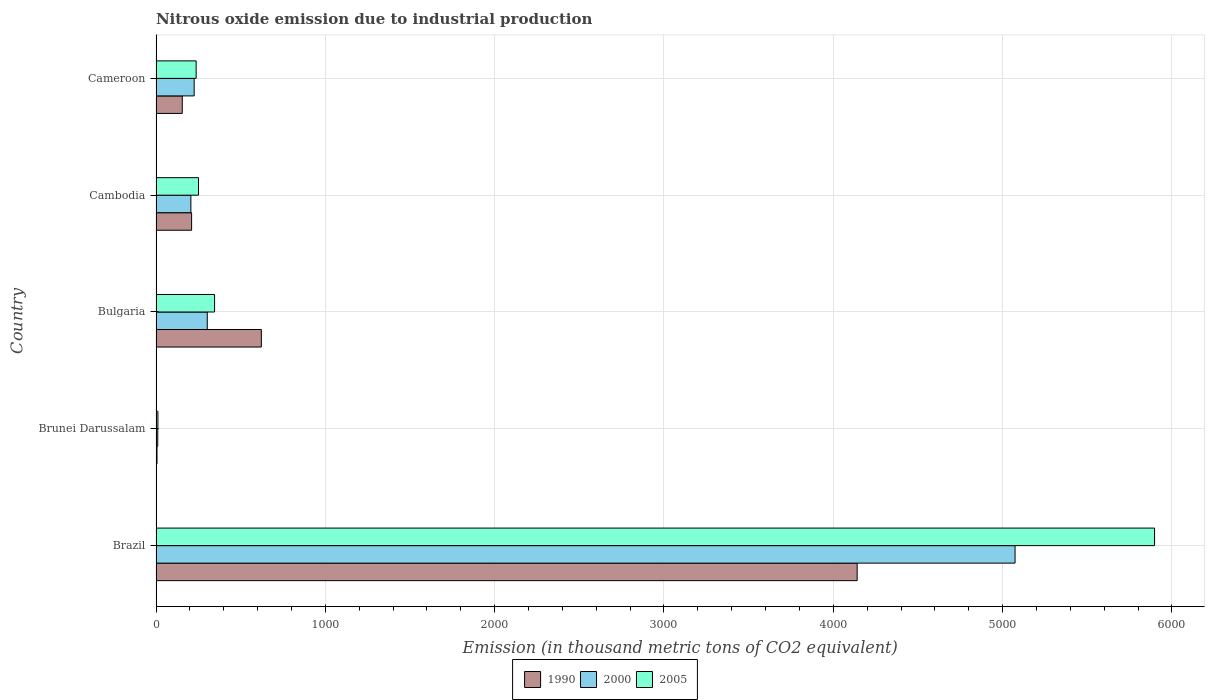How many different coloured bars are there?
Your answer should be very brief. 3. Are the number of bars per tick equal to the number of legend labels?
Your response must be concise. Yes. How many bars are there on the 4th tick from the top?
Your response must be concise. 3. What is the amount of nitrous oxide emitted in 1990 in Brunei Darussalam?
Your answer should be very brief. 5.9. Across all countries, what is the maximum amount of nitrous oxide emitted in 1990?
Your answer should be very brief. 4140.8. Across all countries, what is the minimum amount of nitrous oxide emitted in 2005?
Offer a very short reply. 11.1. In which country was the amount of nitrous oxide emitted in 2005 minimum?
Provide a short and direct response. Brunei Darussalam. What is the total amount of nitrous oxide emitted in 1990 in the graph?
Give a very brief answer. 5133.9. What is the difference between the amount of nitrous oxide emitted in 1990 in Bulgaria and that in Cameroon?
Your answer should be compact. 467. What is the difference between the amount of nitrous oxide emitted in 2005 in Brunei Darussalam and the amount of nitrous oxide emitted in 2000 in Bulgaria?
Give a very brief answer. -291.5. What is the average amount of nitrous oxide emitted in 2005 per country?
Ensure brevity in your answer.  1348.42. What is the difference between the amount of nitrous oxide emitted in 2005 and amount of nitrous oxide emitted in 1990 in Cameroon?
Make the answer very short. 81.9. What is the ratio of the amount of nitrous oxide emitted in 2005 in Brazil to that in Cambodia?
Provide a succinct answer. 23.5. What is the difference between the highest and the second highest amount of nitrous oxide emitted in 2005?
Offer a terse response. 5551.5. What is the difference between the highest and the lowest amount of nitrous oxide emitted in 2000?
Keep it short and to the point. 5063.1. In how many countries, is the amount of nitrous oxide emitted in 2000 greater than the average amount of nitrous oxide emitted in 2000 taken over all countries?
Your response must be concise. 1. Is it the case that in every country, the sum of the amount of nitrous oxide emitted in 2005 and amount of nitrous oxide emitted in 1990 is greater than the amount of nitrous oxide emitted in 2000?
Provide a succinct answer. Yes. What is the difference between two consecutive major ticks on the X-axis?
Ensure brevity in your answer.  1000. Does the graph contain any zero values?
Your answer should be very brief. No. Does the graph contain grids?
Ensure brevity in your answer.  Yes. How many legend labels are there?
Ensure brevity in your answer.  3. What is the title of the graph?
Your response must be concise. Nitrous oxide emission due to industrial production. What is the label or title of the X-axis?
Keep it short and to the point. Emission (in thousand metric tons of CO2 equivalent). What is the label or title of the Y-axis?
Offer a very short reply. Country. What is the Emission (in thousand metric tons of CO2 equivalent) in 1990 in Brazil?
Give a very brief answer. 4140.8. What is the Emission (in thousand metric tons of CO2 equivalent) in 2000 in Brazil?
Ensure brevity in your answer.  5073.4. What is the Emission (in thousand metric tons of CO2 equivalent) in 2005 in Brazil?
Provide a short and direct response. 5897.3. What is the Emission (in thousand metric tons of CO2 equivalent) of 2000 in Brunei Darussalam?
Give a very brief answer. 10.3. What is the Emission (in thousand metric tons of CO2 equivalent) in 2005 in Brunei Darussalam?
Make the answer very short. 11.1. What is the Emission (in thousand metric tons of CO2 equivalent) of 1990 in Bulgaria?
Your response must be concise. 622. What is the Emission (in thousand metric tons of CO2 equivalent) in 2000 in Bulgaria?
Your answer should be very brief. 302.6. What is the Emission (in thousand metric tons of CO2 equivalent) of 2005 in Bulgaria?
Give a very brief answer. 345.8. What is the Emission (in thousand metric tons of CO2 equivalent) in 1990 in Cambodia?
Provide a succinct answer. 210.2. What is the Emission (in thousand metric tons of CO2 equivalent) in 2000 in Cambodia?
Your response must be concise. 205.8. What is the Emission (in thousand metric tons of CO2 equivalent) in 2005 in Cambodia?
Your response must be concise. 251. What is the Emission (in thousand metric tons of CO2 equivalent) in 1990 in Cameroon?
Offer a very short reply. 155. What is the Emission (in thousand metric tons of CO2 equivalent) in 2000 in Cameroon?
Keep it short and to the point. 225.2. What is the Emission (in thousand metric tons of CO2 equivalent) of 2005 in Cameroon?
Ensure brevity in your answer.  236.9. Across all countries, what is the maximum Emission (in thousand metric tons of CO2 equivalent) of 1990?
Make the answer very short. 4140.8. Across all countries, what is the maximum Emission (in thousand metric tons of CO2 equivalent) in 2000?
Make the answer very short. 5073.4. Across all countries, what is the maximum Emission (in thousand metric tons of CO2 equivalent) in 2005?
Provide a succinct answer. 5897.3. What is the total Emission (in thousand metric tons of CO2 equivalent) in 1990 in the graph?
Ensure brevity in your answer.  5133.9. What is the total Emission (in thousand metric tons of CO2 equivalent) of 2000 in the graph?
Provide a succinct answer. 5817.3. What is the total Emission (in thousand metric tons of CO2 equivalent) of 2005 in the graph?
Provide a succinct answer. 6742.1. What is the difference between the Emission (in thousand metric tons of CO2 equivalent) in 1990 in Brazil and that in Brunei Darussalam?
Provide a short and direct response. 4134.9. What is the difference between the Emission (in thousand metric tons of CO2 equivalent) in 2000 in Brazil and that in Brunei Darussalam?
Offer a very short reply. 5063.1. What is the difference between the Emission (in thousand metric tons of CO2 equivalent) in 2005 in Brazil and that in Brunei Darussalam?
Ensure brevity in your answer.  5886.2. What is the difference between the Emission (in thousand metric tons of CO2 equivalent) in 1990 in Brazil and that in Bulgaria?
Offer a terse response. 3518.8. What is the difference between the Emission (in thousand metric tons of CO2 equivalent) of 2000 in Brazil and that in Bulgaria?
Provide a short and direct response. 4770.8. What is the difference between the Emission (in thousand metric tons of CO2 equivalent) of 2005 in Brazil and that in Bulgaria?
Ensure brevity in your answer.  5551.5. What is the difference between the Emission (in thousand metric tons of CO2 equivalent) in 1990 in Brazil and that in Cambodia?
Make the answer very short. 3930.6. What is the difference between the Emission (in thousand metric tons of CO2 equivalent) of 2000 in Brazil and that in Cambodia?
Ensure brevity in your answer.  4867.6. What is the difference between the Emission (in thousand metric tons of CO2 equivalent) in 2005 in Brazil and that in Cambodia?
Provide a succinct answer. 5646.3. What is the difference between the Emission (in thousand metric tons of CO2 equivalent) in 1990 in Brazil and that in Cameroon?
Provide a succinct answer. 3985.8. What is the difference between the Emission (in thousand metric tons of CO2 equivalent) of 2000 in Brazil and that in Cameroon?
Offer a very short reply. 4848.2. What is the difference between the Emission (in thousand metric tons of CO2 equivalent) in 2005 in Brazil and that in Cameroon?
Your answer should be compact. 5660.4. What is the difference between the Emission (in thousand metric tons of CO2 equivalent) of 1990 in Brunei Darussalam and that in Bulgaria?
Give a very brief answer. -616.1. What is the difference between the Emission (in thousand metric tons of CO2 equivalent) in 2000 in Brunei Darussalam and that in Bulgaria?
Provide a short and direct response. -292.3. What is the difference between the Emission (in thousand metric tons of CO2 equivalent) of 2005 in Brunei Darussalam and that in Bulgaria?
Your response must be concise. -334.7. What is the difference between the Emission (in thousand metric tons of CO2 equivalent) of 1990 in Brunei Darussalam and that in Cambodia?
Give a very brief answer. -204.3. What is the difference between the Emission (in thousand metric tons of CO2 equivalent) in 2000 in Brunei Darussalam and that in Cambodia?
Keep it short and to the point. -195.5. What is the difference between the Emission (in thousand metric tons of CO2 equivalent) of 2005 in Brunei Darussalam and that in Cambodia?
Keep it short and to the point. -239.9. What is the difference between the Emission (in thousand metric tons of CO2 equivalent) of 1990 in Brunei Darussalam and that in Cameroon?
Your answer should be very brief. -149.1. What is the difference between the Emission (in thousand metric tons of CO2 equivalent) in 2000 in Brunei Darussalam and that in Cameroon?
Provide a succinct answer. -214.9. What is the difference between the Emission (in thousand metric tons of CO2 equivalent) in 2005 in Brunei Darussalam and that in Cameroon?
Your answer should be very brief. -225.8. What is the difference between the Emission (in thousand metric tons of CO2 equivalent) in 1990 in Bulgaria and that in Cambodia?
Provide a short and direct response. 411.8. What is the difference between the Emission (in thousand metric tons of CO2 equivalent) in 2000 in Bulgaria and that in Cambodia?
Offer a terse response. 96.8. What is the difference between the Emission (in thousand metric tons of CO2 equivalent) in 2005 in Bulgaria and that in Cambodia?
Ensure brevity in your answer.  94.8. What is the difference between the Emission (in thousand metric tons of CO2 equivalent) in 1990 in Bulgaria and that in Cameroon?
Your response must be concise. 467. What is the difference between the Emission (in thousand metric tons of CO2 equivalent) in 2000 in Bulgaria and that in Cameroon?
Offer a very short reply. 77.4. What is the difference between the Emission (in thousand metric tons of CO2 equivalent) of 2005 in Bulgaria and that in Cameroon?
Offer a terse response. 108.9. What is the difference between the Emission (in thousand metric tons of CO2 equivalent) in 1990 in Cambodia and that in Cameroon?
Your response must be concise. 55.2. What is the difference between the Emission (in thousand metric tons of CO2 equivalent) in 2000 in Cambodia and that in Cameroon?
Offer a very short reply. -19.4. What is the difference between the Emission (in thousand metric tons of CO2 equivalent) in 2005 in Cambodia and that in Cameroon?
Your answer should be compact. 14.1. What is the difference between the Emission (in thousand metric tons of CO2 equivalent) of 1990 in Brazil and the Emission (in thousand metric tons of CO2 equivalent) of 2000 in Brunei Darussalam?
Ensure brevity in your answer.  4130.5. What is the difference between the Emission (in thousand metric tons of CO2 equivalent) in 1990 in Brazil and the Emission (in thousand metric tons of CO2 equivalent) in 2005 in Brunei Darussalam?
Keep it short and to the point. 4129.7. What is the difference between the Emission (in thousand metric tons of CO2 equivalent) of 2000 in Brazil and the Emission (in thousand metric tons of CO2 equivalent) of 2005 in Brunei Darussalam?
Provide a short and direct response. 5062.3. What is the difference between the Emission (in thousand metric tons of CO2 equivalent) in 1990 in Brazil and the Emission (in thousand metric tons of CO2 equivalent) in 2000 in Bulgaria?
Make the answer very short. 3838.2. What is the difference between the Emission (in thousand metric tons of CO2 equivalent) of 1990 in Brazil and the Emission (in thousand metric tons of CO2 equivalent) of 2005 in Bulgaria?
Give a very brief answer. 3795. What is the difference between the Emission (in thousand metric tons of CO2 equivalent) of 2000 in Brazil and the Emission (in thousand metric tons of CO2 equivalent) of 2005 in Bulgaria?
Your answer should be very brief. 4727.6. What is the difference between the Emission (in thousand metric tons of CO2 equivalent) in 1990 in Brazil and the Emission (in thousand metric tons of CO2 equivalent) in 2000 in Cambodia?
Offer a terse response. 3935. What is the difference between the Emission (in thousand metric tons of CO2 equivalent) of 1990 in Brazil and the Emission (in thousand metric tons of CO2 equivalent) of 2005 in Cambodia?
Your answer should be very brief. 3889.8. What is the difference between the Emission (in thousand metric tons of CO2 equivalent) of 2000 in Brazil and the Emission (in thousand metric tons of CO2 equivalent) of 2005 in Cambodia?
Keep it short and to the point. 4822.4. What is the difference between the Emission (in thousand metric tons of CO2 equivalent) in 1990 in Brazil and the Emission (in thousand metric tons of CO2 equivalent) in 2000 in Cameroon?
Make the answer very short. 3915.6. What is the difference between the Emission (in thousand metric tons of CO2 equivalent) in 1990 in Brazil and the Emission (in thousand metric tons of CO2 equivalent) in 2005 in Cameroon?
Ensure brevity in your answer.  3903.9. What is the difference between the Emission (in thousand metric tons of CO2 equivalent) in 2000 in Brazil and the Emission (in thousand metric tons of CO2 equivalent) in 2005 in Cameroon?
Keep it short and to the point. 4836.5. What is the difference between the Emission (in thousand metric tons of CO2 equivalent) in 1990 in Brunei Darussalam and the Emission (in thousand metric tons of CO2 equivalent) in 2000 in Bulgaria?
Offer a terse response. -296.7. What is the difference between the Emission (in thousand metric tons of CO2 equivalent) in 1990 in Brunei Darussalam and the Emission (in thousand metric tons of CO2 equivalent) in 2005 in Bulgaria?
Give a very brief answer. -339.9. What is the difference between the Emission (in thousand metric tons of CO2 equivalent) in 2000 in Brunei Darussalam and the Emission (in thousand metric tons of CO2 equivalent) in 2005 in Bulgaria?
Offer a terse response. -335.5. What is the difference between the Emission (in thousand metric tons of CO2 equivalent) of 1990 in Brunei Darussalam and the Emission (in thousand metric tons of CO2 equivalent) of 2000 in Cambodia?
Keep it short and to the point. -199.9. What is the difference between the Emission (in thousand metric tons of CO2 equivalent) in 1990 in Brunei Darussalam and the Emission (in thousand metric tons of CO2 equivalent) in 2005 in Cambodia?
Your response must be concise. -245.1. What is the difference between the Emission (in thousand metric tons of CO2 equivalent) in 2000 in Brunei Darussalam and the Emission (in thousand metric tons of CO2 equivalent) in 2005 in Cambodia?
Keep it short and to the point. -240.7. What is the difference between the Emission (in thousand metric tons of CO2 equivalent) of 1990 in Brunei Darussalam and the Emission (in thousand metric tons of CO2 equivalent) of 2000 in Cameroon?
Offer a very short reply. -219.3. What is the difference between the Emission (in thousand metric tons of CO2 equivalent) in 1990 in Brunei Darussalam and the Emission (in thousand metric tons of CO2 equivalent) in 2005 in Cameroon?
Make the answer very short. -231. What is the difference between the Emission (in thousand metric tons of CO2 equivalent) in 2000 in Brunei Darussalam and the Emission (in thousand metric tons of CO2 equivalent) in 2005 in Cameroon?
Ensure brevity in your answer.  -226.6. What is the difference between the Emission (in thousand metric tons of CO2 equivalent) in 1990 in Bulgaria and the Emission (in thousand metric tons of CO2 equivalent) in 2000 in Cambodia?
Your answer should be very brief. 416.2. What is the difference between the Emission (in thousand metric tons of CO2 equivalent) in 1990 in Bulgaria and the Emission (in thousand metric tons of CO2 equivalent) in 2005 in Cambodia?
Keep it short and to the point. 371. What is the difference between the Emission (in thousand metric tons of CO2 equivalent) in 2000 in Bulgaria and the Emission (in thousand metric tons of CO2 equivalent) in 2005 in Cambodia?
Provide a short and direct response. 51.6. What is the difference between the Emission (in thousand metric tons of CO2 equivalent) of 1990 in Bulgaria and the Emission (in thousand metric tons of CO2 equivalent) of 2000 in Cameroon?
Make the answer very short. 396.8. What is the difference between the Emission (in thousand metric tons of CO2 equivalent) in 1990 in Bulgaria and the Emission (in thousand metric tons of CO2 equivalent) in 2005 in Cameroon?
Provide a succinct answer. 385.1. What is the difference between the Emission (in thousand metric tons of CO2 equivalent) in 2000 in Bulgaria and the Emission (in thousand metric tons of CO2 equivalent) in 2005 in Cameroon?
Offer a very short reply. 65.7. What is the difference between the Emission (in thousand metric tons of CO2 equivalent) of 1990 in Cambodia and the Emission (in thousand metric tons of CO2 equivalent) of 2000 in Cameroon?
Your answer should be very brief. -15. What is the difference between the Emission (in thousand metric tons of CO2 equivalent) in 1990 in Cambodia and the Emission (in thousand metric tons of CO2 equivalent) in 2005 in Cameroon?
Ensure brevity in your answer.  -26.7. What is the difference between the Emission (in thousand metric tons of CO2 equivalent) in 2000 in Cambodia and the Emission (in thousand metric tons of CO2 equivalent) in 2005 in Cameroon?
Your response must be concise. -31.1. What is the average Emission (in thousand metric tons of CO2 equivalent) in 1990 per country?
Your response must be concise. 1026.78. What is the average Emission (in thousand metric tons of CO2 equivalent) of 2000 per country?
Your response must be concise. 1163.46. What is the average Emission (in thousand metric tons of CO2 equivalent) in 2005 per country?
Provide a short and direct response. 1348.42. What is the difference between the Emission (in thousand metric tons of CO2 equivalent) in 1990 and Emission (in thousand metric tons of CO2 equivalent) in 2000 in Brazil?
Keep it short and to the point. -932.6. What is the difference between the Emission (in thousand metric tons of CO2 equivalent) in 1990 and Emission (in thousand metric tons of CO2 equivalent) in 2005 in Brazil?
Your response must be concise. -1756.5. What is the difference between the Emission (in thousand metric tons of CO2 equivalent) in 2000 and Emission (in thousand metric tons of CO2 equivalent) in 2005 in Brazil?
Give a very brief answer. -823.9. What is the difference between the Emission (in thousand metric tons of CO2 equivalent) in 1990 and Emission (in thousand metric tons of CO2 equivalent) in 2005 in Brunei Darussalam?
Your response must be concise. -5.2. What is the difference between the Emission (in thousand metric tons of CO2 equivalent) in 2000 and Emission (in thousand metric tons of CO2 equivalent) in 2005 in Brunei Darussalam?
Offer a very short reply. -0.8. What is the difference between the Emission (in thousand metric tons of CO2 equivalent) in 1990 and Emission (in thousand metric tons of CO2 equivalent) in 2000 in Bulgaria?
Your answer should be compact. 319.4. What is the difference between the Emission (in thousand metric tons of CO2 equivalent) in 1990 and Emission (in thousand metric tons of CO2 equivalent) in 2005 in Bulgaria?
Offer a very short reply. 276.2. What is the difference between the Emission (in thousand metric tons of CO2 equivalent) in 2000 and Emission (in thousand metric tons of CO2 equivalent) in 2005 in Bulgaria?
Offer a terse response. -43.2. What is the difference between the Emission (in thousand metric tons of CO2 equivalent) of 1990 and Emission (in thousand metric tons of CO2 equivalent) of 2005 in Cambodia?
Your answer should be compact. -40.8. What is the difference between the Emission (in thousand metric tons of CO2 equivalent) in 2000 and Emission (in thousand metric tons of CO2 equivalent) in 2005 in Cambodia?
Your answer should be compact. -45.2. What is the difference between the Emission (in thousand metric tons of CO2 equivalent) in 1990 and Emission (in thousand metric tons of CO2 equivalent) in 2000 in Cameroon?
Provide a succinct answer. -70.2. What is the difference between the Emission (in thousand metric tons of CO2 equivalent) in 1990 and Emission (in thousand metric tons of CO2 equivalent) in 2005 in Cameroon?
Provide a short and direct response. -81.9. What is the difference between the Emission (in thousand metric tons of CO2 equivalent) of 2000 and Emission (in thousand metric tons of CO2 equivalent) of 2005 in Cameroon?
Provide a short and direct response. -11.7. What is the ratio of the Emission (in thousand metric tons of CO2 equivalent) in 1990 in Brazil to that in Brunei Darussalam?
Give a very brief answer. 701.83. What is the ratio of the Emission (in thousand metric tons of CO2 equivalent) of 2000 in Brazil to that in Brunei Darussalam?
Offer a very short reply. 492.56. What is the ratio of the Emission (in thousand metric tons of CO2 equivalent) in 2005 in Brazil to that in Brunei Darussalam?
Offer a terse response. 531.29. What is the ratio of the Emission (in thousand metric tons of CO2 equivalent) of 1990 in Brazil to that in Bulgaria?
Your response must be concise. 6.66. What is the ratio of the Emission (in thousand metric tons of CO2 equivalent) in 2000 in Brazil to that in Bulgaria?
Keep it short and to the point. 16.77. What is the ratio of the Emission (in thousand metric tons of CO2 equivalent) in 2005 in Brazil to that in Bulgaria?
Your answer should be compact. 17.05. What is the ratio of the Emission (in thousand metric tons of CO2 equivalent) of 1990 in Brazil to that in Cambodia?
Keep it short and to the point. 19.7. What is the ratio of the Emission (in thousand metric tons of CO2 equivalent) in 2000 in Brazil to that in Cambodia?
Your answer should be compact. 24.65. What is the ratio of the Emission (in thousand metric tons of CO2 equivalent) in 2005 in Brazil to that in Cambodia?
Your answer should be very brief. 23.5. What is the ratio of the Emission (in thousand metric tons of CO2 equivalent) of 1990 in Brazil to that in Cameroon?
Provide a succinct answer. 26.71. What is the ratio of the Emission (in thousand metric tons of CO2 equivalent) in 2000 in Brazil to that in Cameroon?
Ensure brevity in your answer.  22.53. What is the ratio of the Emission (in thousand metric tons of CO2 equivalent) in 2005 in Brazil to that in Cameroon?
Provide a succinct answer. 24.89. What is the ratio of the Emission (in thousand metric tons of CO2 equivalent) of 1990 in Brunei Darussalam to that in Bulgaria?
Keep it short and to the point. 0.01. What is the ratio of the Emission (in thousand metric tons of CO2 equivalent) in 2000 in Brunei Darussalam to that in Bulgaria?
Offer a terse response. 0.03. What is the ratio of the Emission (in thousand metric tons of CO2 equivalent) in 2005 in Brunei Darussalam to that in Bulgaria?
Keep it short and to the point. 0.03. What is the ratio of the Emission (in thousand metric tons of CO2 equivalent) in 1990 in Brunei Darussalam to that in Cambodia?
Ensure brevity in your answer.  0.03. What is the ratio of the Emission (in thousand metric tons of CO2 equivalent) of 2005 in Brunei Darussalam to that in Cambodia?
Offer a terse response. 0.04. What is the ratio of the Emission (in thousand metric tons of CO2 equivalent) in 1990 in Brunei Darussalam to that in Cameroon?
Your answer should be compact. 0.04. What is the ratio of the Emission (in thousand metric tons of CO2 equivalent) of 2000 in Brunei Darussalam to that in Cameroon?
Your answer should be compact. 0.05. What is the ratio of the Emission (in thousand metric tons of CO2 equivalent) of 2005 in Brunei Darussalam to that in Cameroon?
Keep it short and to the point. 0.05. What is the ratio of the Emission (in thousand metric tons of CO2 equivalent) of 1990 in Bulgaria to that in Cambodia?
Provide a short and direct response. 2.96. What is the ratio of the Emission (in thousand metric tons of CO2 equivalent) of 2000 in Bulgaria to that in Cambodia?
Ensure brevity in your answer.  1.47. What is the ratio of the Emission (in thousand metric tons of CO2 equivalent) in 2005 in Bulgaria to that in Cambodia?
Your answer should be compact. 1.38. What is the ratio of the Emission (in thousand metric tons of CO2 equivalent) of 1990 in Bulgaria to that in Cameroon?
Give a very brief answer. 4.01. What is the ratio of the Emission (in thousand metric tons of CO2 equivalent) in 2000 in Bulgaria to that in Cameroon?
Ensure brevity in your answer.  1.34. What is the ratio of the Emission (in thousand metric tons of CO2 equivalent) of 2005 in Bulgaria to that in Cameroon?
Offer a terse response. 1.46. What is the ratio of the Emission (in thousand metric tons of CO2 equivalent) in 1990 in Cambodia to that in Cameroon?
Keep it short and to the point. 1.36. What is the ratio of the Emission (in thousand metric tons of CO2 equivalent) in 2000 in Cambodia to that in Cameroon?
Your answer should be very brief. 0.91. What is the ratio of the Emission (in thousand metric tons of CO2 equivalent) in 2005 in Cambodia to that in Cameroon?
Provide a short and direct response. 1.06. What is the difference between the highest and the second highest Emission (in thousand metric tons of CO2 equivalent) of 1990?
Offer a terse response. 3518.8. What is the difference between the highest and the second highest Emission (in thousand metric tons of CO2 equivalent) of 2000?
Give a very brief answer. 4770.8. What is the difference between the highest and the second highest Emission (in thousand metric tons of CO2 equivalent) in 2005?
Offer a terse response. 5551.5. What is the difference between the highest and the lowest Emission (in thousand metric tons of CO2 equivalent) of 1990?
Give a very brief answer. 4134.9. What is the difference between the highest and the lowest Emission (in thousand metric tons of CO2 equivalent) in 2000?
Your response must be concise. 5063.1. What is the difference between the highest and the lowest Emission (in thousand metric tons of CO2 equivalent) in 2005?
Provide a short and direct response. 5886.2. 